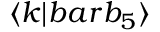<formula> <loc_0><loc_0><loc_500><loc_500>\langle k | b a r { b } _ { 5 } \rangle</formula> 